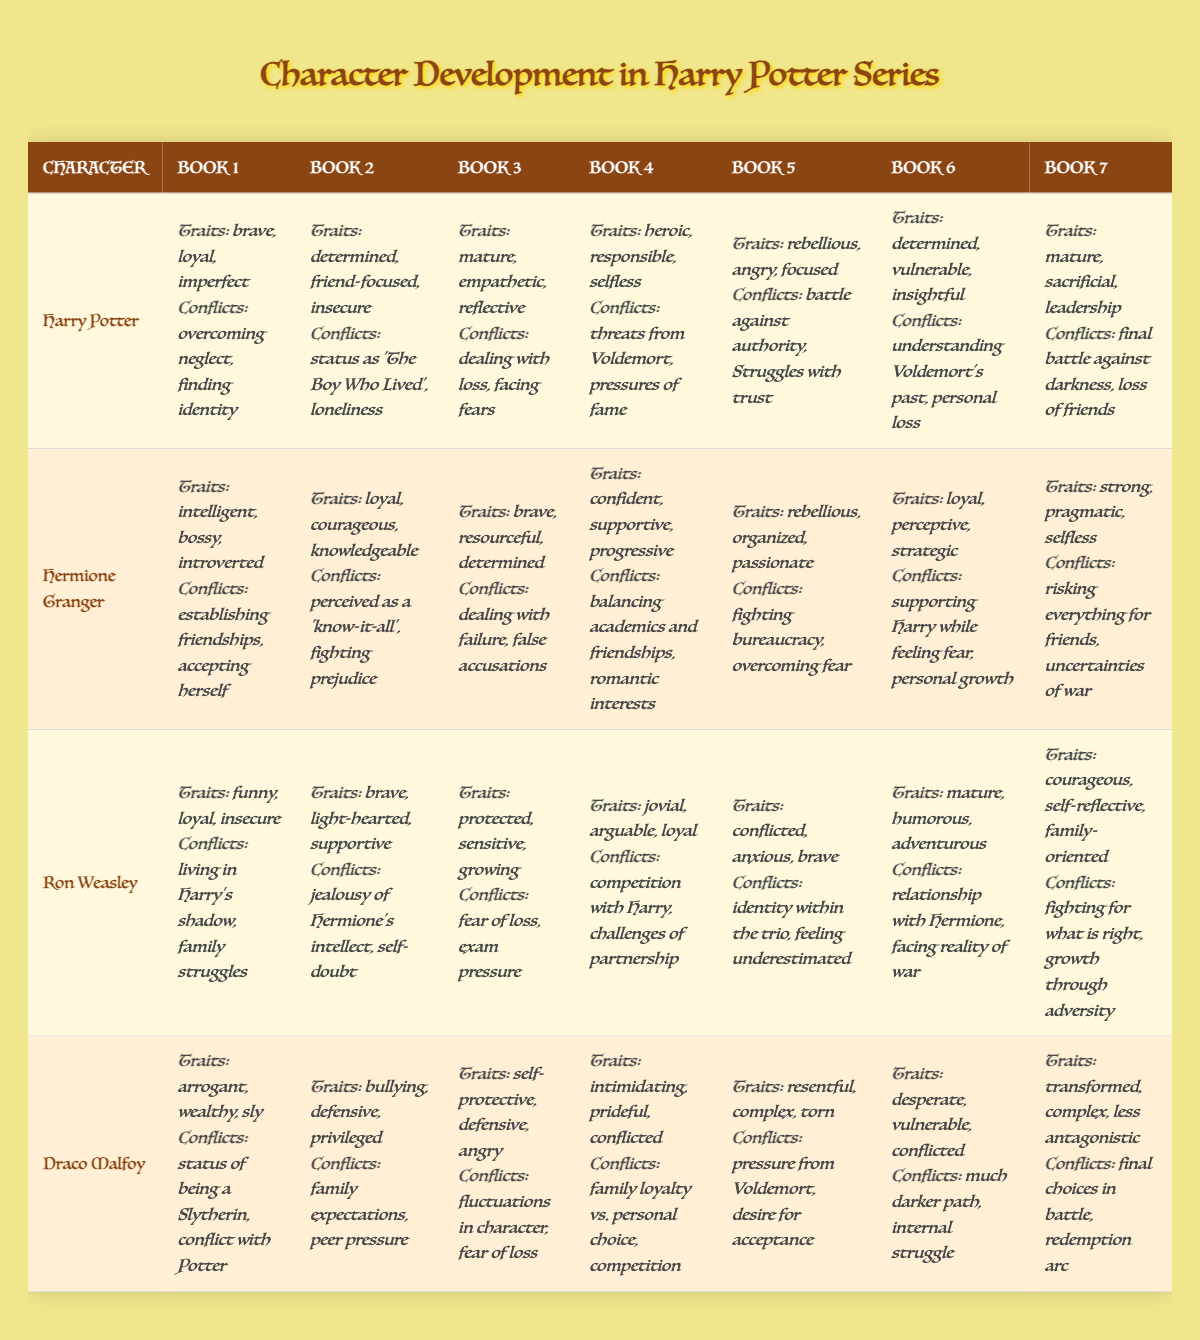What traits are shown for Hermione Granger in Book 4? Referring to the table under Hermione Granger's row for Book 4, the traits listed are confident, supportive, and progressive.
Answer: confident, supportive, progressive Which character shows a change from insecure traits to more courageous ones? Looking at Ron Weasley, in Book 1 he is described as funny, loyal, and insecure, while in Book 7 he demonstrates courageous, self-reflective, and family-oriented traits. This suggests an evolution from insecurity to courage.
Answer: Ron Weasley Did Draco Malfoy have a conflict related to family expectations in Book 2? The table indicates that in Book 2, Draco Malfoy’s conflicts include family expectations along with peer pressure, confirming that this is true.
Answer: Yes In which book does Harry Potter demonstrate traits of being mature, empathetic, and reflective? The table shows that in Book 3, under Harry Potter's profile, the traits of being mature, empathetic, and reflective are listed.
Answer: Book 3 How many characters exhibit rebellious traits throughout the series? The data shows that Harry Potter exhibits rebellious traits in Book 5, Hermione Granger also in Book 5, and Ron Weasley exhibits conflicted traits in Book 5, what implies a sort of rebellion. Therefore, three characters exhibit some form of rebellion across their arcs.
Answer: Three characters Which character's conflicts in Book 6 relate to Voldemort and personal loss? By observing the table, Harry Potter’s conflicts listed in Book 6 are about understanding Voldemort's past and personal loss, confirming that Harry Potter is the right answer.
Answer: Harry Potter Compare the conflicted traits of Ron Weasley in Book 5 and Draco Malfoy in Book 6. Ron's conflicts in Book 5 include identity within the trio and feeling underestimated, while Draco's conflicts in Book 6 show desperation and internal struggle. This comparison indicates Ron is dealing with his role among friends, while Draco is more focused on his internal crises.
Answer: They are different in focus; Ron on identity and Draco on internal struggles What is the predominant trait of Draco Malfoy in Book 1? According to the table, Draco Malfoy is characterized as arrogant, wealthy, and sly in Book 1, making arrogance his predominant trait.
Answer: Arrogant Do any characters show a significant development from being protective to mature? Ron Weasley starts as protected in Book 3 and transitions to mature in Book 6, signaling significant growth in his character development.
Answer: Yes, Ron Weasley 